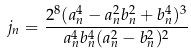<formula> <loc_0><loc_0><loc_500><loc_500>j _ { n } = \frac { 2 ^ { 8 } ( a _ { n } ^ { 4 } - a _ { n } ^ { 2 } b _ { n } ^ { 2 } + b _ { n } ^ { 4 } ) ^ { 3 } } { a _ { n } ^ { 4 } b _ { n } ^ { 4 } ( a _ { n } ^ { 2 } - b _ { n } ^ { 2 } ) ^ { 2 } }</formula> 